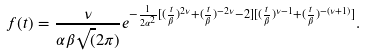Convert formula to latex. <formula><loc_0><loc_0><loc_500><loc_500>f ( t ) = \frac { \nu } { \alpha \beta \sqrt { ( } 2 \pi ) } e ^ { - { \frac { 1 } { 2 \alpha ^ { 2 } } [ ( \frac { t } { \beta } ) ^ { 2 \nu } + ( \frac { t } { \beta } ) ^ { - 2 \nu } - 2 ] [ ( \frac { t } { \beta } ) ^ { \nu - 1 } + ( \frac { t } { \beta } ) ^ { - ( \nu + 1 ) } ] } } .</formula> 